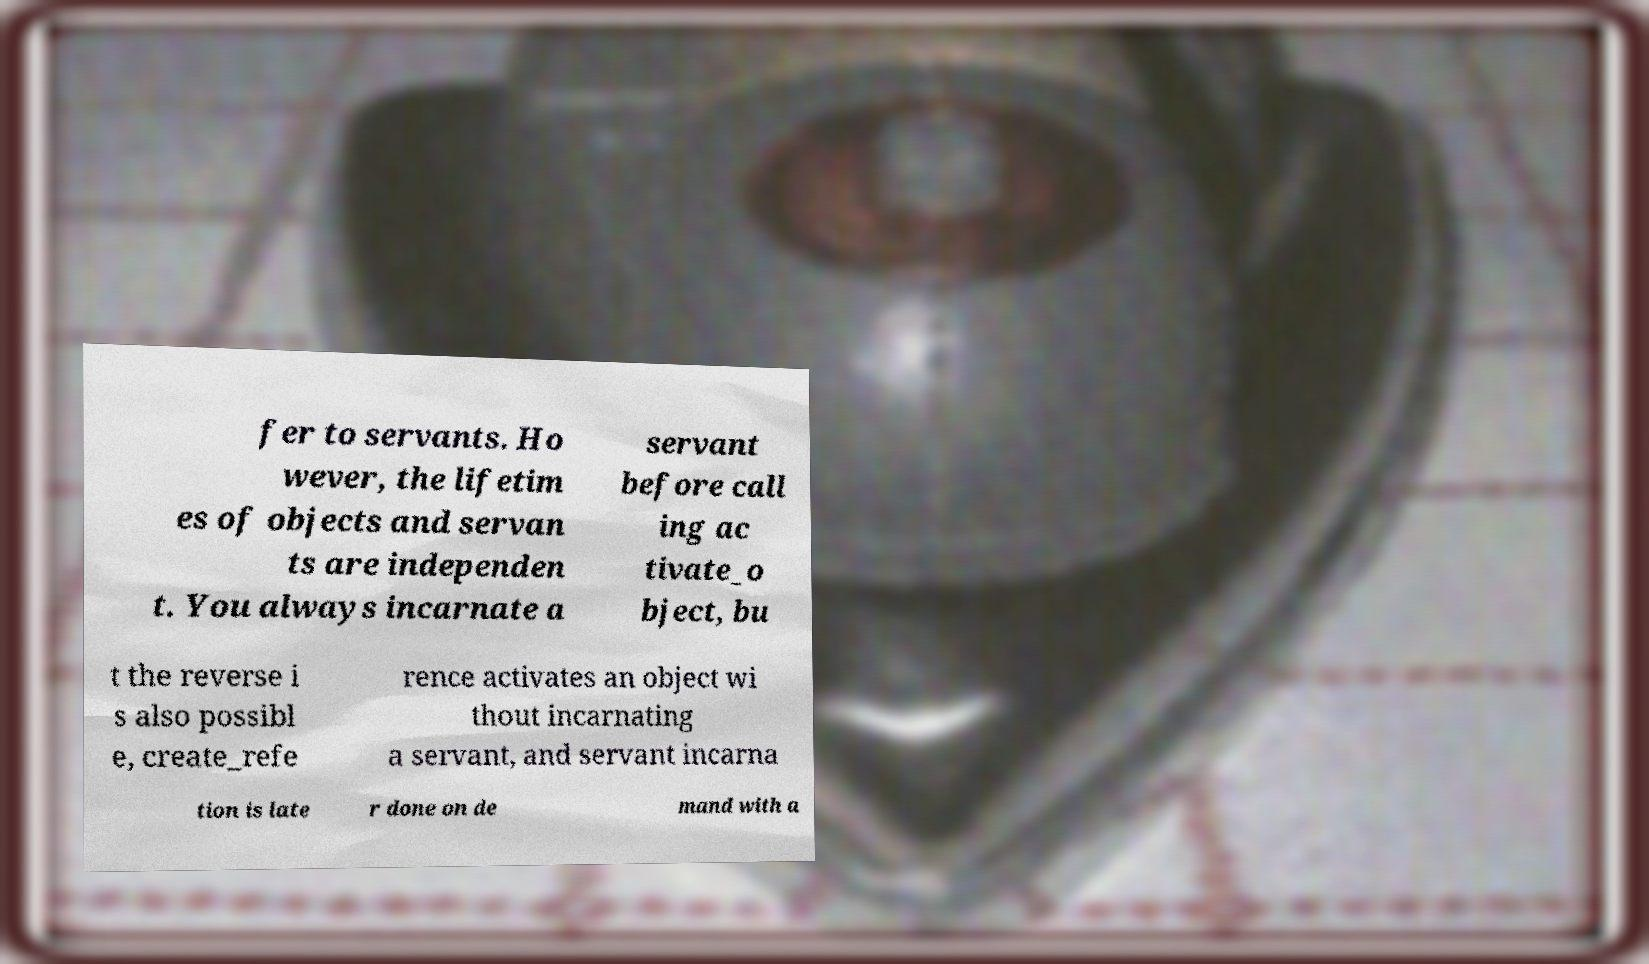For documentation purposes, I need the text within this image transcribed. Could you provide that? fer to servants. Ho wever, the lifetim es of objects and servan ts are independen t. You always incarnate a servant before call ing ac tivate_o bject, bu t the reverse i s also possibl e, create_refe rence activates an object wi thout incarnating a servant, and servant incarna tion is late r done on de mand with a 